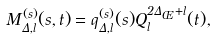Convert formula to latex. <formula><loc_0><loc_0><loc_500><loc_500>M _ { \Delta , l } ^ { ( s ) } ( s , t ) = q _ { \Delta , l } ^ { ( s ) } ( s ) Q _ { l } ^ { 2 \Delta _ { \phi } + l } ( t ) ,</formula> 